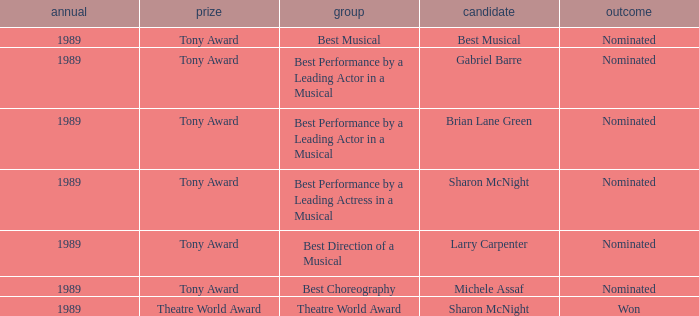What year was michele assaf nominated 1989.0. 